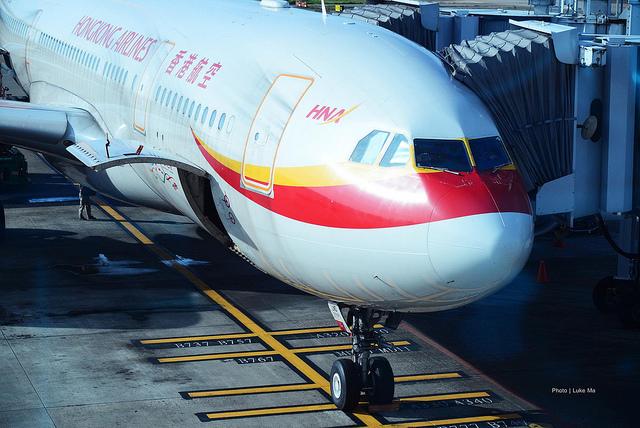What is the color of the plane?
Answer briefly. White. What is the names of the plane?
Give a very brief answer. Hong kong airlines. What color is the plane?
Write a very short answer. White. Is there any people?
Short answer required. No. What color are the wheels?
Short answer required. Black. What era does this plane come from?
Write a very short answer. 21st. 